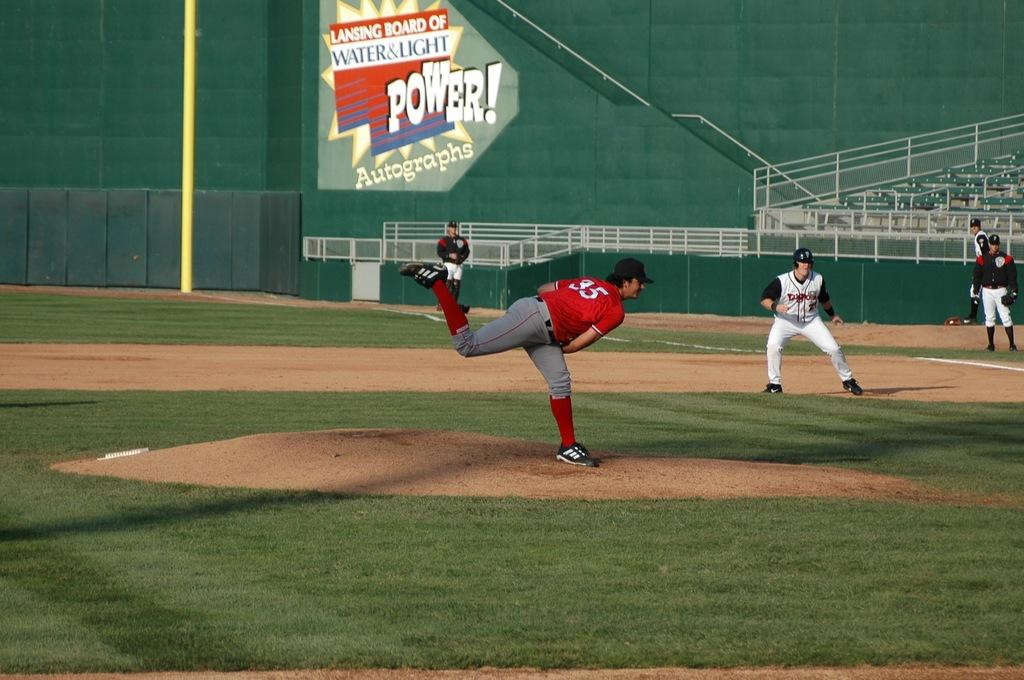<image>
Relay a brief, clear account of the picture shown. Baseball game with a large sign reading Lansing Board of Water & Light 